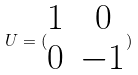Convert formula to latex. <formula><loc_0><loc_0><loc_500><loc_500>U = ( \begin{matrix} 1 & 0 \\ 0 & - 1 \end{matrix} )</formula> 